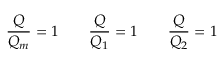Convert formula to latex. <formula><loc_0><loc_0><loc_500><loc_500>\frac { Q } { Q _ { m } } = 1 \quad \frac { Q } { Q _ { 1 } } = 1 \quad \frac { Q } { Q _ { 2 } } = 1</formula> 